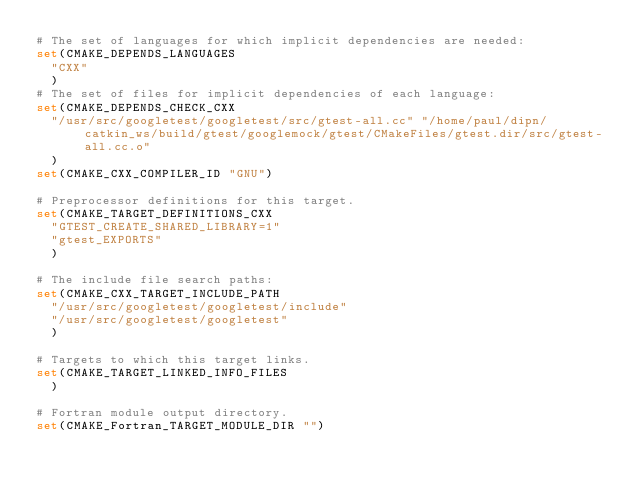Convert code to text. <code><loc_0><loc_0><loc_500><loc_500><_CMake_># The set of languages for which implicit dependencies are needed:
set(CMAKE_DEPENDS_LANGUAGES
  "CXX"
  )
# The set of files for implicit dependencies of each language:
set(CMAKE_DEPENDS_CHECK_CXX
  "/usr/src/googletest/googletest/src/gtest-all.cc" "/home/paul/dipn/catkin_ws/build/gtest/googlemock/gtest/CMakeFiles/gtest.dir/src/gtest-all.cc.o"
  )
set(CMAKE_CXX_COMPILER_ID "GNU")

# Preprocessor definitions for this target.
set(CMAKE_TARGET_DEFINITIONS_CXX
  "GTEST_CREATE_SHARED_LIBRARY=1"
  "gtest_EXPORTS"
  )

# The include file search paths:
set(CMAKE_CXX_TARGET_INCLUDE_PATH
  "/usr/src/googletest/googletest/include"
  "/usr/src/googletest/googletest"
  )

# Targets to which this target links.
set(CMAKE_TARGET_LINKED_INFO_FILES
  )

# Fortran module output directory.
set(CMAKE_Fortran_TARGET_MODULE_DIR "")
</code> 